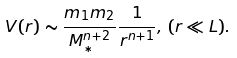<formula> <loc_0><loc_0><loc_500><loc_500>V ( r ) \sim \frac { m _ { 1 } m _ { 2 } } { M _ { * } ^ { n + 2 } } \frac { 1 } { r ^ { n + 1 } } , \, ( r \ll L ) .</formula> 